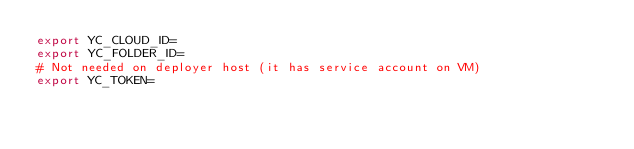Convert code to text. <code><loc_0><loc_0><loc_500><loc_500><_Bash_>export YC_CLOUD_ID=
export YC_FOLDER_ID=
# Not needed on deployer host (it has service account on VM)
export YC_TOKEN=
</code> 